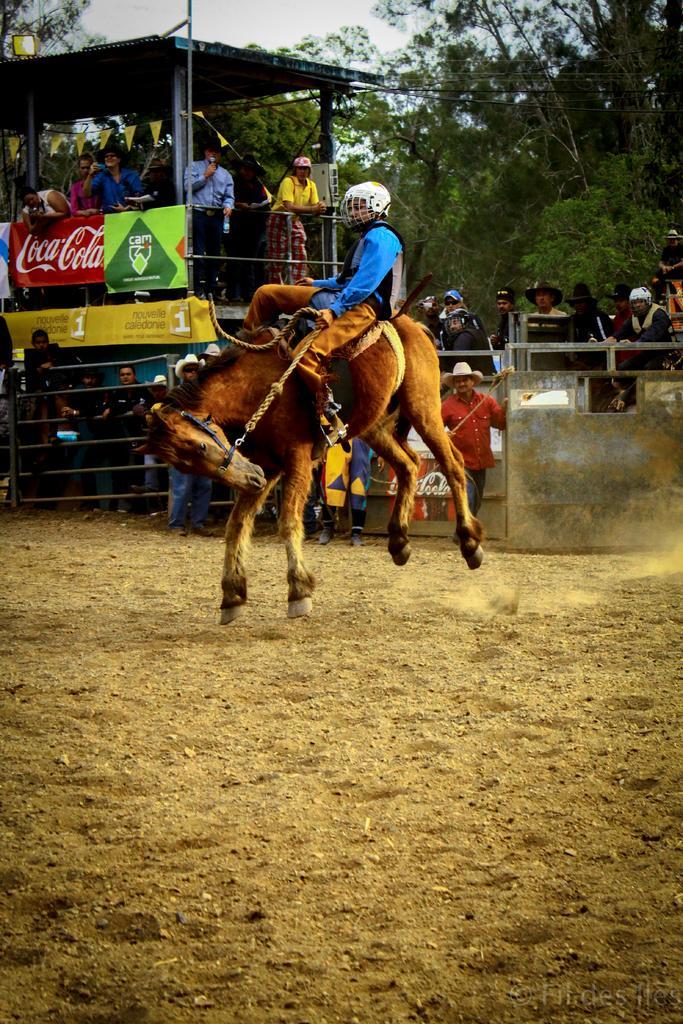Could you give a brief overview of what you see in this image? In the center of the image a man is sitting on a horse and riding the horse. And wearing a helmet. In the background of the image we can see group of people are standing and also we can see the tent, boards, barricades are present. At the bottom of the image ground is there. On the right side of the image trees are present. At the top of the image sky is there. 